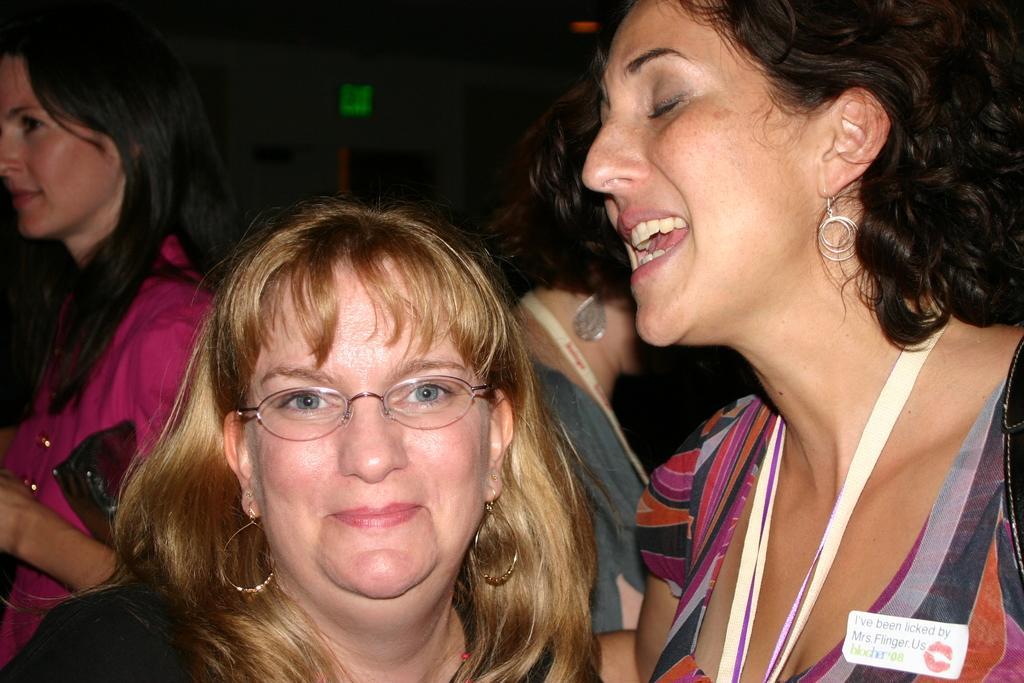Can you describe this image briefly? In this image, I can see few people standing. This looks like a badge, which is attached to the dress. I think these are the tags. The background looks dark. 